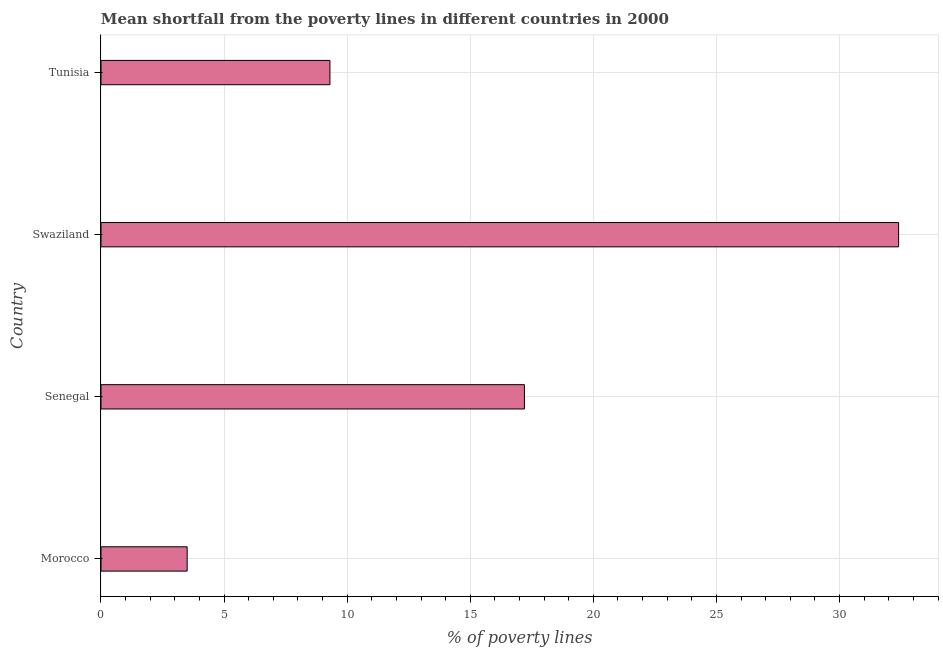Does the graph contain any zero values?
Offer a very short reply. No. Does the graph contain grids?
Give a very brief answer. Yes. What is the title of the graph?
Make the answer very short. Mean shortfall from the poverty lines in different countries in 2000. What is the label or title of the X-axis?
Make the answer very short. % of poverty lines. What is the poverty gap at national poverty lines in Tunisia?
Ensure brevity in your answer.  9.3. Across all countries, what is the maximum poverty gap at national poverty lines?
Keep it short and to the point. 32.4. In which country was the poverty gap at national poverty lines maximum?
Ensure brevity in your answer.  Swaziland. In which country was the poverty gap at national poverty lines minimum?
Give a very brief answer. Morocco. What is the sum of the poverty gap at national poverty lines?
Your response must be concise. 62.4. What is the difference between the poverty gap at national poverty lines in Senegal and Swaziland?
Give a very brief answer. -15.2. What is the median poverty gap at national poverty lines?
Your answer should be compact. 13.25. In how many countries, is the poverty gap at national poverty lines greater than 12 %?
Offer a terse response. 2. What is the ratio of the poverty gap at national poverty lines in Senegal to that in Tunisia?
Your answer should be compact. 1.85. Is the difference between the poverty gap at national poverty lines in Morocco and Swaziland greater than the difference between any two countries?
Provide a succinct answer. Yes. What is the difference between the highest and the lowest poverty gap at national poverty lines?
Keep it short and to the point. 28.9. How many bars are there?
Offer a terse response. 4. What is the difference between two consecutive major ticks on the X-axis?
Your response must be concise. 5. What is the % of poverty lines of Morocco?
Ensure brevity in your answer.  3.5. What is the % of poverty lines of Swaziland?
Provide a short and direct response. 32.4. What is the difference between the % of poverty lines in Morocco and Senegal?
Your answer should be very brief. -13.7. What is the difference between the % of poverty lines in Morocco and Swaziland?
Make the answer very short. -28.9. What is the difference between the % of poverty lines in Senegal and Swaziland?
Your response must be concise. -15.2. What is the difference between the % of poverty lines in Swaziland and Tunisia?
Your response must be concise. 23.1. What is the ratio of the % of poverty lines in Morocco to that in Senegal?
Offer a very short reply. 0.2. What is the ratio of the % of poverty lines in Morocco to that in Swaziland?
Make the answer very short. 0.11. What is the ratio of the % of poverty lines in Morocco to that in Tunisia?
Your response must be concise. 0.38. What is the ratio of the % of poverty lines in Senegal to that in Swaziland?
Your answer should be compact. 0.53. What is the ratio of the % of poverty lines in Senegal to that in Tunisia?
Your answer should be very brief. 1.85. What is the ratio of the % of poverty lines in Swaziland to that in Tunisia?
Your response must be concise. 3.48. 